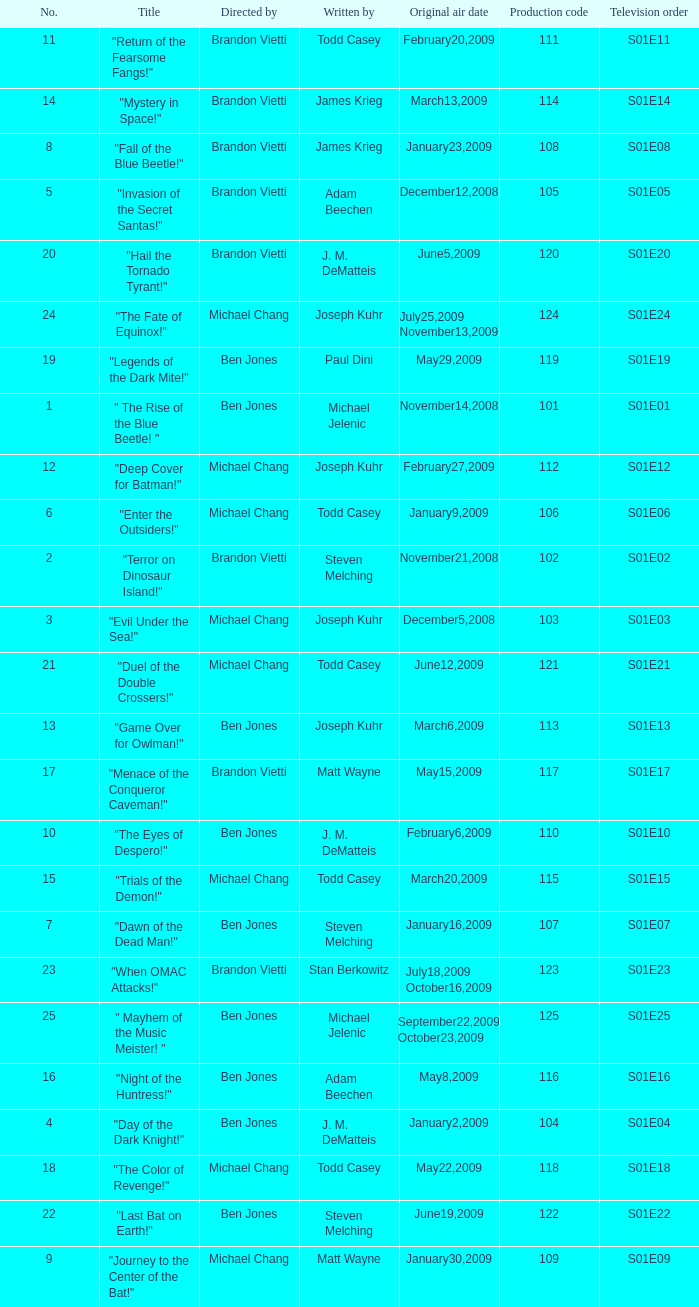Give me the full table as a dictionary. {'header': ['No.', 'Title', 'Directed by', 'Written by', 'Original air date', 'Production code', 'Television order'], 'rows': [['11', '"Return of the Fearsome Fangs!"', 'Brandon Vietti', 'Todd Casey', 'February20,2009', '111', 'S01E11'], ['14', '"Mystery in Space!"', 'Brandon Vietti', 'James Krieg', 'March13,2009', '114', 'S01E14'], ['8', '"Fall of the Blue Beetle!"', 'Brandon Vietti', 'James Krieg', 'January23,2009', '108', 'S01E08'], ['5', '"Invasion of the Secret Santas!"', 'Brandon Vietti', 'Adam Beechen', 'December12,2008', '105', 'S01E05'], ['20', '"Hail the Tornado Tyrant!"', 'Brandon Vietti', 'J. M. DeMatteis', 'June5,2009', '120', 'S01E20'], ['24', '"The Fate of Equinox!"', 'Michael Chang', 'Joseph Kuhr', 'July25,2009 November13,2009', '124', 'S01E24'], ['19', '"Legends of the Dark Mite!"', 'Ben Jones', 'Paul Dini', 'May29,2009', '119', 'S01E19'], ['1', '" The Rise of the Blue Beetle! "', 'Ben Jones', 'Michael Jelenic', 'November14,2008', '101', 'S01E01'], ['12', '"Deep Cover for Batman!"', 'Michael Chang', 'Joseph Kuhr', 'February27,2009', '112', 'S01E12'], ['6', '"Enter the Outsiders!"', 'Michael Chang', 'Todd Casey', 'January9,2009', '106', 'S01E06'], ['2', '"Terror on Dinosaur Island!"', 'Brandon Vietti', 'Steven Melching', 'November21,2008', '102', 'S01E02'], ['3', '"Evil Under the Sea!"', 'Michael Chang', 'Joseph Kuhr', 'December5,2008', '103', 'S01E03'], ['21', '"Duel of the Double Crossers!"', 'Michael Chang', 'Todd Casey', 'June12,2009', '121', 'S01E21'], ['13', '"Game Over for Owlman!"', 'Ben Jones', 'Joseph Kuhr', 'March6,2009', '113', 'S01E13'], ['17', '"Menace of the Conqueror Caveman!"', 'Brandon Vietti', 'Matt Wayne', 'May15,2009', '117', 'S01E17'], ['10', '"The Eyes of Despero!"', 'Ben Jones', 'J. M. DeMatteis', 'February6,2009', '110', 'S01E10'], ['15', '"Trials of the Demon!"', 'Michael Chang', 'Todd Casey', 'March20,2009', '115', 'S01E15'], ['7', '"Dawn of the Dead Man!"', 'Ben Jones', 'Steven Melching', 'January16,2009', '107', 'S01E07'], ['23', '"When OMAC Attacks!"', 'Brandon Vietti', 'Stan Berkowitz', 'July18,2009 October16,2009', '123', 'S01E23'], ['25', '" Mayhem of the Music Meister! "', 'Ben Jones', 'Michael Jelenic', 'September22,2009 October23,2009', '125', 'S01E25'], ['16', '"Night of the Huntress!"', 'Ben Jones', 'Adam Beechen', 'May8,2009', '116', 'S01E16'], ['4', '"Day of the Dark Knight!"', 'Ben Jones', 'J. M. DeMatteis', 'January2,2009', '104', 'S01E04'], ['18', '"The Color of Revenge!"', 'Michael Chang', 'Todd Casey', 'May22,2009', '118', 'S01E18'], ['22', '"Last Bat on Earth!"', 'Ben Jones', 'Steven Melching', 'June19,2009', '122', 'S01E22'], ['9', '"Journey to the Center of the Bat!"', 'Michael Chang', 'Matt Wayne', 'January30,2009', '109', 'S01E09']]} Who wrote s01e06 Todd Casey. 